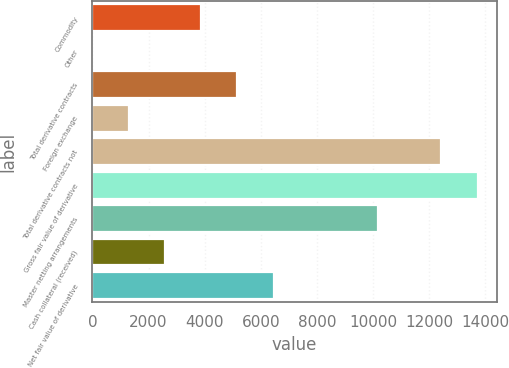Convert chart. <chart><loc_0><loc_0><loc_500><loc_500><bar_chart><fcel>Commodity<fcel>Other<fcel>Total derivative contracts<fcel>Foreign exchange<fcel>Total derivative contracts not<fcel>Gross fair value of derivative<fcel>Master netting arrangements<fcel>Cash collateral (received)<fcel>Net fair value of derivative<nl><fcel>3877.1<fcel>2<fcel>5168.8<fcel>1293.7<fcel>12434<fcel>13725.7<fcel>10178<fcel>2585.4<fcel>6460.5<nl></chart> 